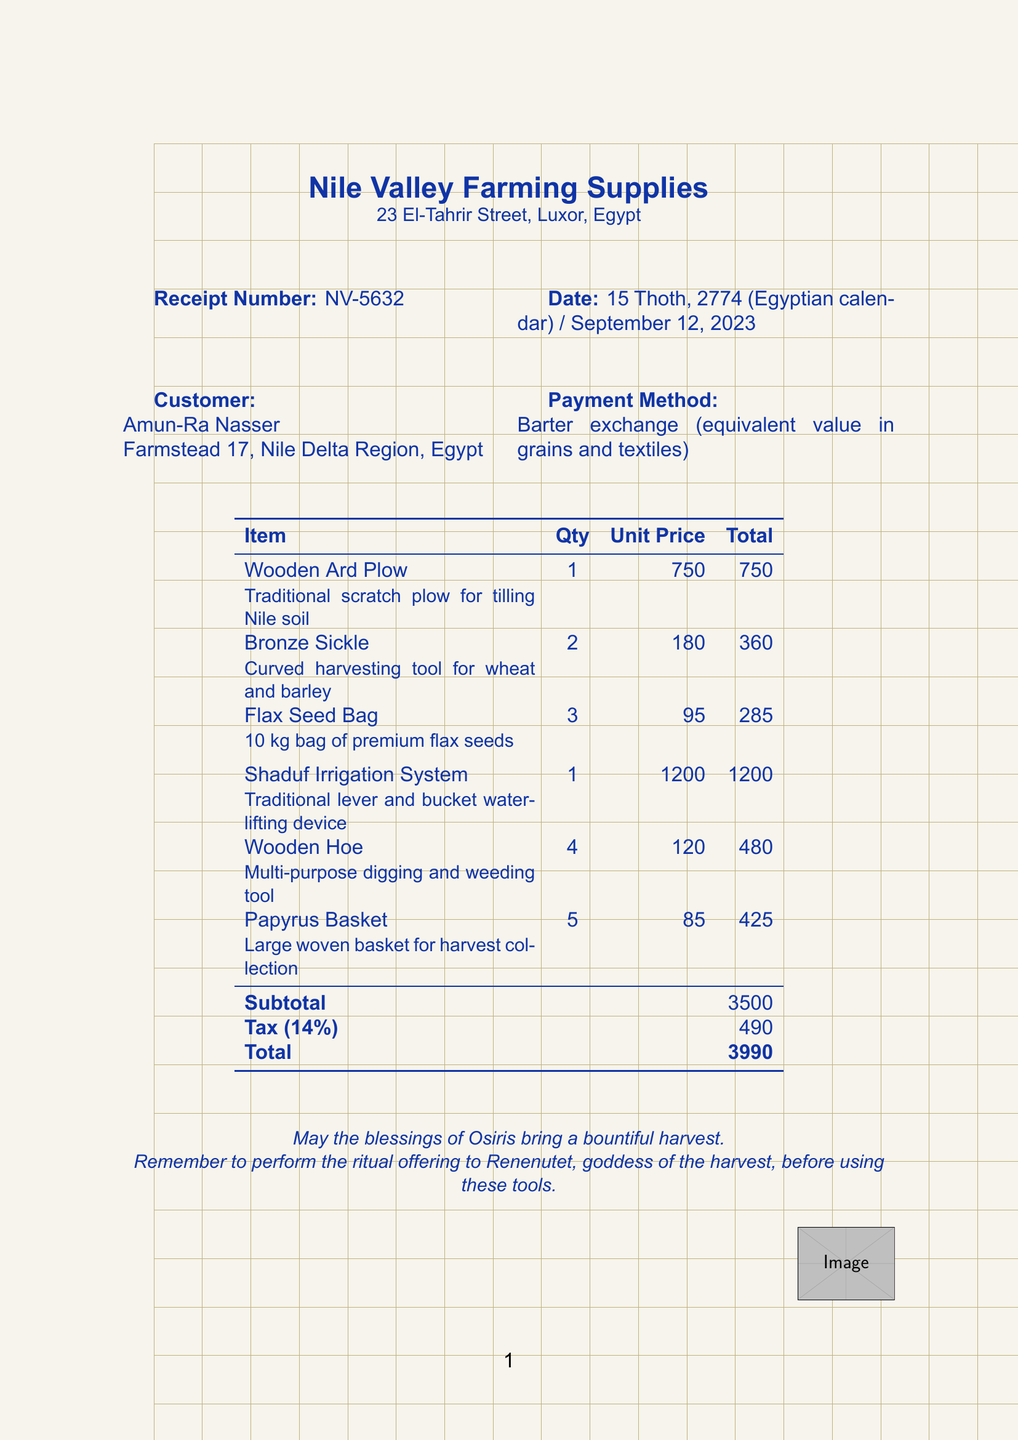What is the merchant's name? The merchant's name is listed at the top of the receipt.
Answer: Nile Valley Farming Supplies What is the date of the transaction? The date is specified in the document as the date of the receipt issuance.
Answer: 15 Thoth, 2774 (Egyptian calendar) / September 12, 2023 How many Wooden Hoes were purchased? The quantity of Wooden Hoes can be found in the item list on the receipt.
Answer: 4 What is the subtotal amount? The subtotal is clearly stated in the summary of costs at the bottom of the itemized list.
Answer: 3500 What is the tax rate applied to the purchase? The tax rate is listed directly in the calculation section of the receipt.
Answer: 14% What is the total amount due? The total amount is calculated and displayed at the end of the receipt.
Answer: 3990 What payment method was used? The payment method is detailed in the customer information section of the receipt.
Answer: Barter exchange (equivalent value in grains and textiles) What is the description of the Shaduf Irrigation System? The description of the Shaduf is provided under the item name on the receipt.
Answer: Traditional lever and bucket water-lifting device What is the customer’s address? The customer’s address is listed in the customer details section of the receipt.
Answer: Farmstead 17, Nile Delta Region, Egypt 